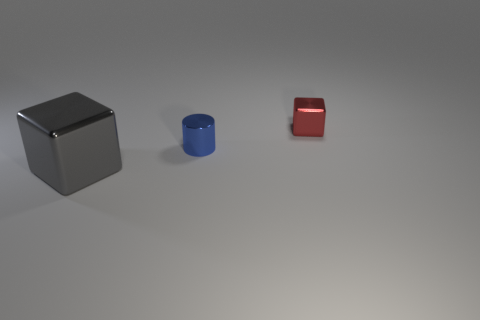Is there a large gray matte cylinder?
Provide a succinct answer. No. Is there another cube that has the same material as the red block?
Keep it short and to the point. Yes. What color is the cylinder?
Give a very brief answer. Blue. What is the color of the block that is the same size as the blue cylinder?
Your answer should be very brief. Red. What number of metallic objects are either small blue things or large blocks?
Offer a very short reply. 2. What number of objects are to the left of the small red metal object and right of the gray metallic object?
Your response must be concise. 1. Are there any other things that are the same shape as the small blue object?
Your answer should be very brief. No. How many other things are the same size as the blue thing?
Make the answer very short. 1. Does the block in front of the small metal block have the same size as the metallic thing that is behind the small blue metallic object?
Provide a succinct answer. No. How many things are big gray metallic things or shiny things behind the large gray cube?
Your response must be concise. 3. 